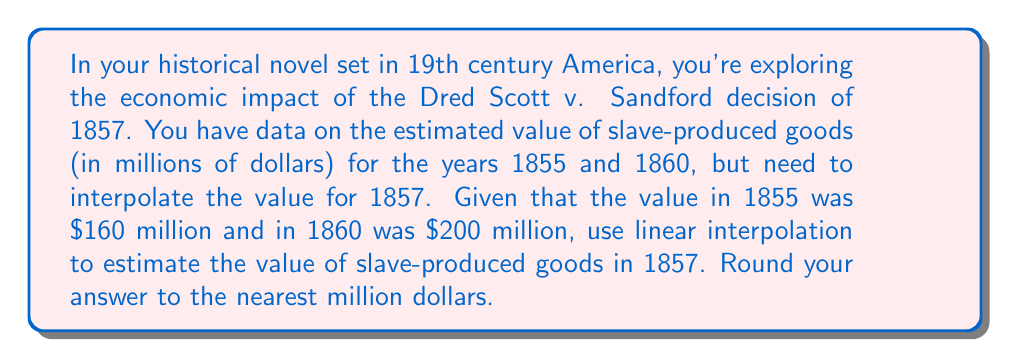Can you answer this question? To solve this problem using linear interpolation, we'll follow these steps:

1) Let's define our variables:
   $x_1 = 1855$, $y_1 = 160$ (million dollars)
   $x_2 = 1860$, $y_2 = 200$ (million dollars)
   $x = 1857$ (the year we're interpolating for)

2) The linear interpolation formula is:

   $$y = y_1 + \frac{(x - x_1)(y_2 - y_1)}{(x_2 - x_1)}$$

3) Plugging in our values:

   $$y = 160 + \frac{(1857 - 1855)(200 - 160)}{(1860 - 1855)}$$

4) Simplify:

   $$y = 160 + \frac{2 * 40}{5}$$

5) Calculate:

   $$y = 160 + \frac{80}{5} = 160 + 16 = 176$$

6) Round to the nearest million:

   $y \approx 176$ million dollars

Therefore, the estimated value of slave-produced goods in 1857 was approximately 176 million dollars.
Answer: $176 million 